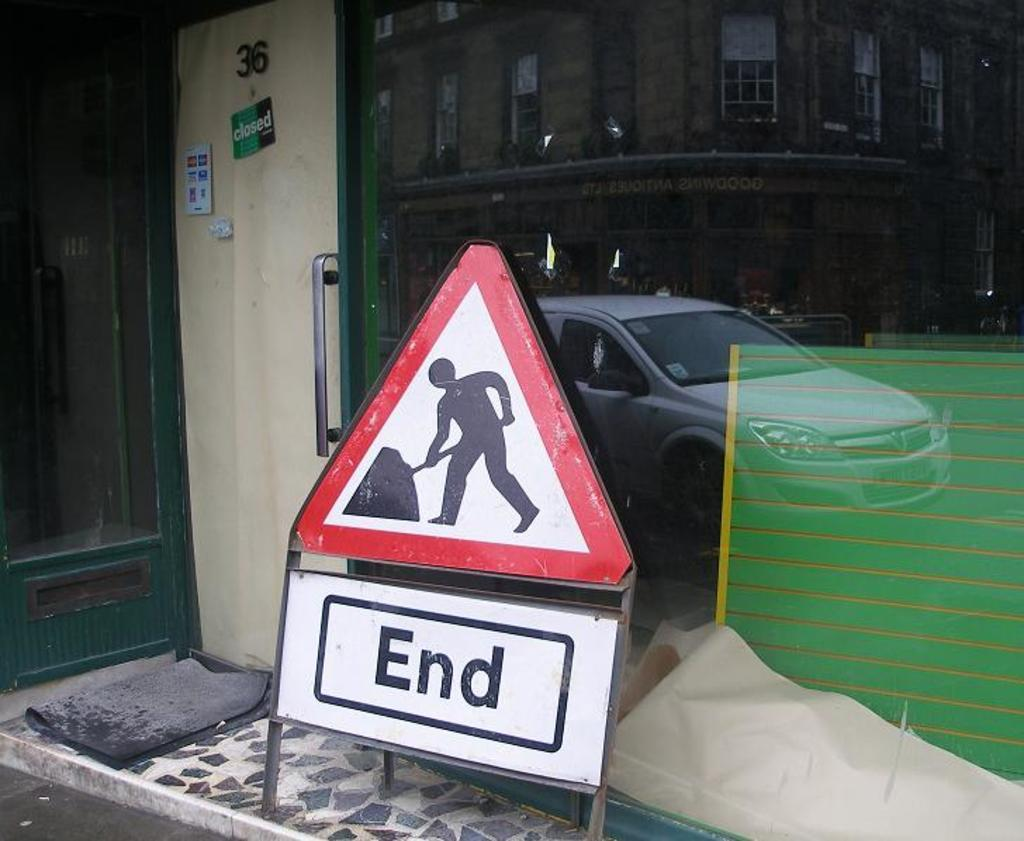Provide a one-sentence caption for the provided image. A sign with a red triangle on it shows a person digging with a sign below it that says, "End". 